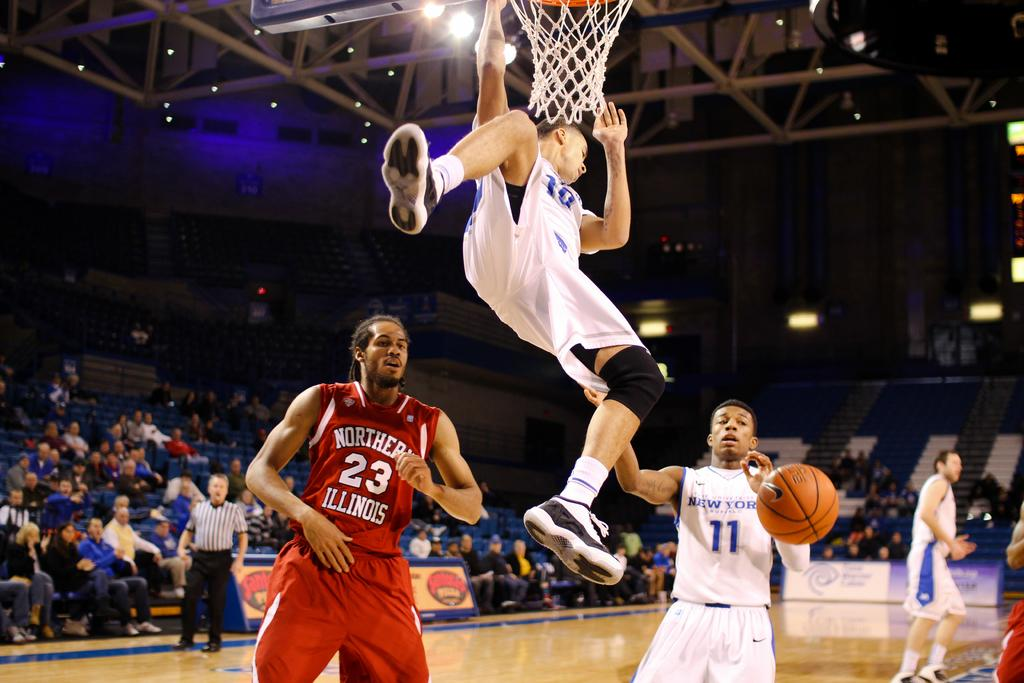<image>
Write a terse but informative summary of the picture. A basketball player from the Northern Illinois college is under the basketball goal. 